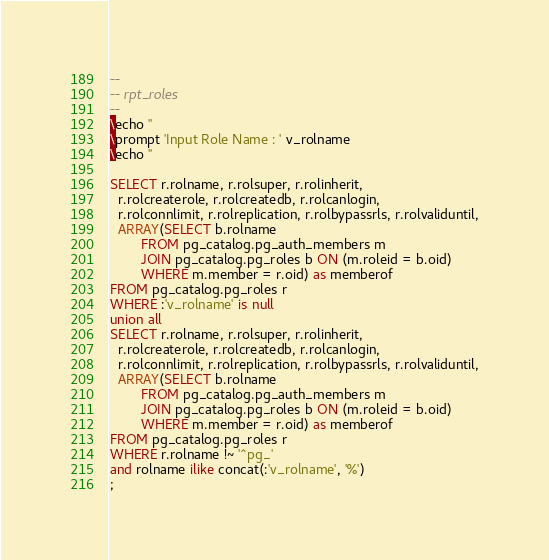<code> <loc_0><loc_0><loc_500><loc_500><_SQL_>--
-- rpt_roles
-- 
\echo ''
\prompt 'Input Role Name : ' v_rolname
\echo ''

SELECT r.rolname, r.rolsuper, r.rolinherit,
  r.rolcreaterole, r.rolcreatedb, r.rolcanlogin,
  r.rolconnlimit, r.rolreplication, r.rolbypassrls, r.rolvaliduntil,
  ARRAY(SELECT b.rolname
        FROM pg_catalog.pg_auth_members m
        JOIN pg_catalog.pg_roles b ON (m.roleid = b.oid)
        WHERE m.member = r.oid) as memberof
FROM pg_catalog.pg_roles r
WHERE :'v_rolname' is null
union all
SELECT r.rolname, r.rolsuper, r.rolinherit,
  r.rolcreaterole, r.rolcreatedb, r.rolcanlogin,
  r.rolconnlimit, r.rolreplication, r.rolbypassrls, r.rolvaliduntil,
  ARRAY(SELECT b.rolname
        FROM pg_catalog.pg_auth_members m
        JOIN pg_catalog.pg_roles b ON (m.roleid = b.oid)
        WHERE m.member = r.oid) as memberof
FROM pg_catalog.pg_roles r
WHERE r.rolname !~ '^pg_'
and rolname ilike concat(:'v_rolname', '%')
;</code> 